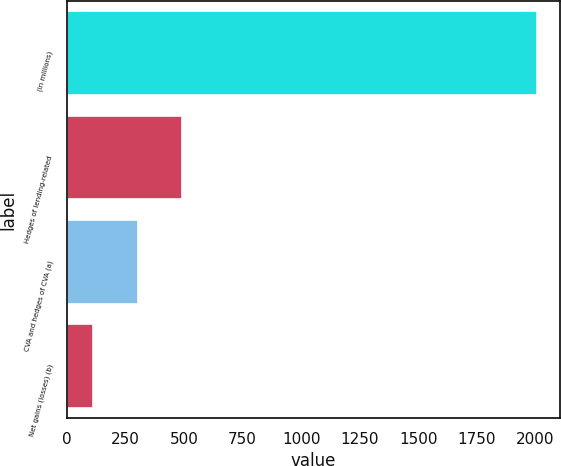Convert chart. <chart><loc_0><loc_0><loc_500><loc_500><bar_chart><fcel>(in millions)<fcel>Hedges of lending-related<fcel>CVA and hedges of CVA (a)<fcel>Net gains (losses) (b)<nl><fcel>2006<fcel>491.6<fcel>302.3<fcel>113<nl></chart> 